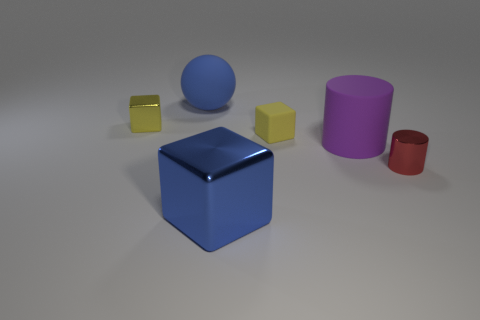How many metallic objects are both on the left side of the purple cylinder and in front of the tiny yellow rubber thing?
Your answer should be compact. 1. There is a blue object to the right of the blue matte sphere; is its size the same as the blue rubber thing?
Provide a short and direct response. Yes. Is there a metallic cylinder of the same color as the rubber cylinder?
Ensure brevity in your answer.  No. What size is the purple thing that is made of the same material as the large blue ball?
Provide a short and direct response. Large. Is the number of large blue shiny cubes behind the purple cylinder greater than the number of red cylinders to the left of the matte ball?
Your answer should be very brief. No. How many other things are made of the same material as the tiny red object?
Offer a very short reply. 2. Are the big blue thing that is in front of the small red metal cylinder and the blue sphere made of the same material?
Your answer should be compact. No. The large purple rubber object has what shape?
Offer a terse response. Cylinder. Is the number of metal cubes behind the large blue cube greater than the number of purple matte things?
Ensure brevity in your answer.  No. Is there anything else that is the same shape as the big purple rubber thing?
Make the answer very short. Yes. 